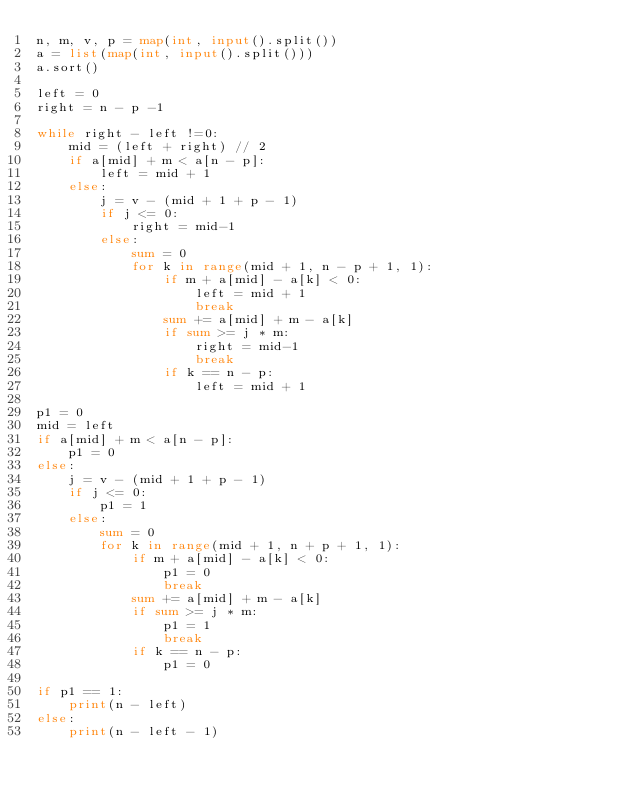Convert code to text. <code><loc_0><loc_0><loc_500><loc_500><_Python_>n, m, v, p = map(int, input().split())
a = list(map(int, input().split()))
a.sort()

left = 0
right = n - p -1

while right - left !=0:
    mid = (left + right) // 2
    if a[mid] + m < a[n - p]:
        left = mid + 1
    else:
        j = v - (mid + 1 + p - 1)
        if j <= 0:
            right = mid-1
        else:
            sum = 0
            for k in range(mid + 1, n - p + 1, 1):
                if m + a[mid] - a[k] < 0:
                    left = mid + 1
                    break
                sum += a[mid] + m - a[k]
                if sum >= j * m:
                    right = mid-1
                    break
                if k == n - p:
                    left = mid + 1

p1 = 0
mid = left
if a[mid] + m < a[n - p]:
    p1 = 0
else:
    j = v - (mid + 1 + p - 1)
    if j <= 0:
        p1 = 1
    else:
        sum = 0
        for k in range(mid + 1, n + p + 1, 1):
            if m + a[mid] - a[k] < 0:
                p1 = 0
                break
            sum += a[mid] + m - a[k]
            if sum >= j * m:
                p1 = 1
                break
            if k == n - p:
                p1 = 0

if p1 == 1:
    print(n - left)
else:
    print(n - left - 1)</code> 